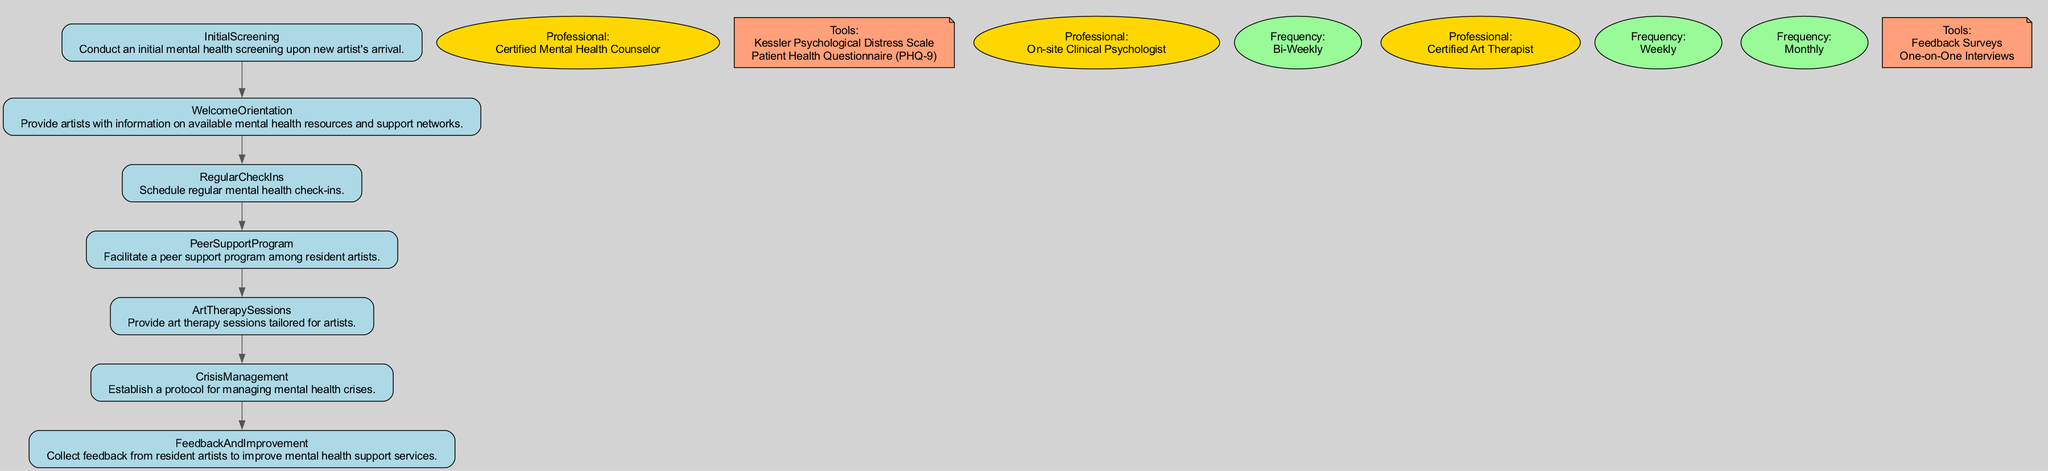What is the first step in the Mental Health Support Pathway? The first step is the "Initial Screening," which is the first node in the pathway.
Answer: Initial Screening How often are regular mental health check-ins scheduled? The frequency for regular mental health check-ins is stated in the "Regular Check Ins" node, which specifies "Bi-Weekly."
Answer: Bi-Weekly Who conducts the initial mental health screening? The "Initial Screening" node includes the professional responsible for this step, which is "Certified Mental Health Counselor."
Answer: Certified Mental Health Counselor What type of sessions are provided weekly in the pathway? The "Art Therapy Sessions" node describes the type of sessions given on a weekly basis.
Answer: Art Therapy Sessions What is the purpose of the Feedback and Improvement step? In the "Feedback And Improvement" node, it outlines the goal of this step: to collect feedback from resident artists to enhance mental health support services.
Answer: Collect feedback to improve services Which group is facilitated in the Peer Support Program? The "Peer Support Program" node identifies that it facilitates "peer support among resident artists" through group meetings and mentoring.
Answer: Peer support among resident artists What resources are provided during the Welcome Orientation? In the "WelcomeOrientation" node, it lists resources such as "Welcome Guide" and "Emergency Contact List."
Answer: Welcome Guide, Emergency Contact List What immediate actions are outlined in the Crisis Management step? The "Crisis Management" node specifies immediate actions such as "Mental Health Hotline access" and "Emergency Counseling Session."
Answer: Mental Health Hotline access, Emergency Counseling Session Which professional is responsible for the Art Therapy Sessions? The "Art Therapy Sessions" node mentions that a "Certified Art Therapist" is the professional responsible for conducting these sessions.
Answer: Certified Art Therapist 